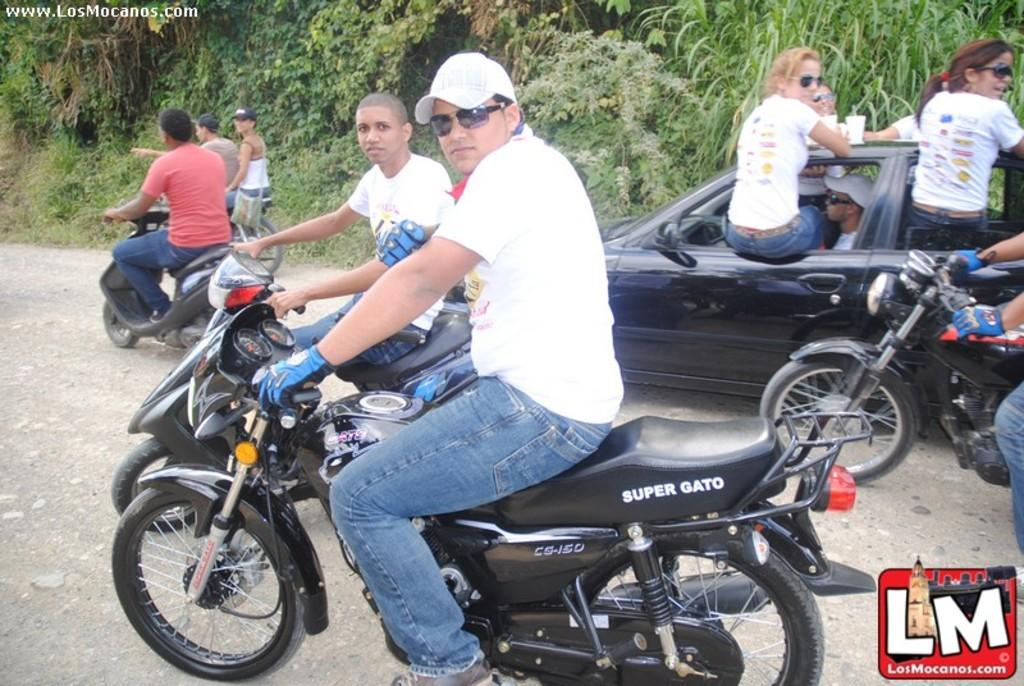What can be seen in the image? There are people in the image. How are the people traveling in the image? Some people are on a two-wheeler vehicle, while others are in a car. What is visible in the background of the image? There are trees in the background of the image. Can you see any spots on the self in the image? There is no reference to a spot or self in the image, so it is not possible to answer that question. 